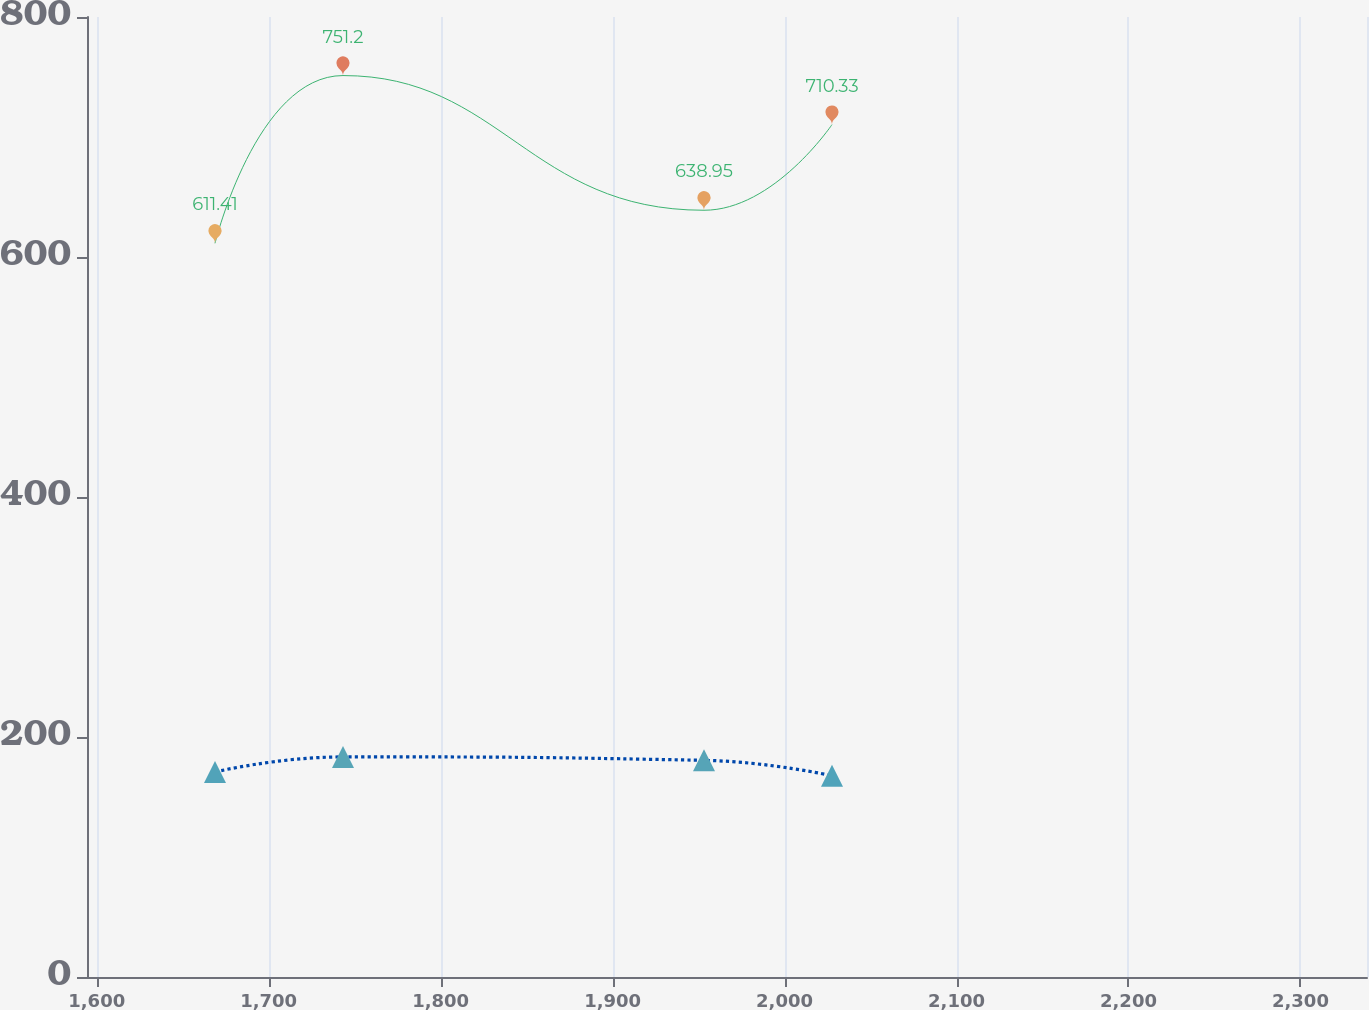Convert chart. <chart><loc_0><loc_0><loc_500><loc_500><line_chart><ecel><fcel>Pension $_{ }$<fcel>Retiree Medical  and Other<nl><fcel>1668.79<fcel>611.41<fcel>170.88<nl><fcel>1743.22<fcel>751.2<fcel>183.4<nl><fcel>1953.14<fcel>638.95<fcel>180.56<nl><fcel>2027.58<fcel>710.33<fcel>167.69<nl><fcel>2413.14<fcel>886.78<fcel>196.06<nl></chart> 